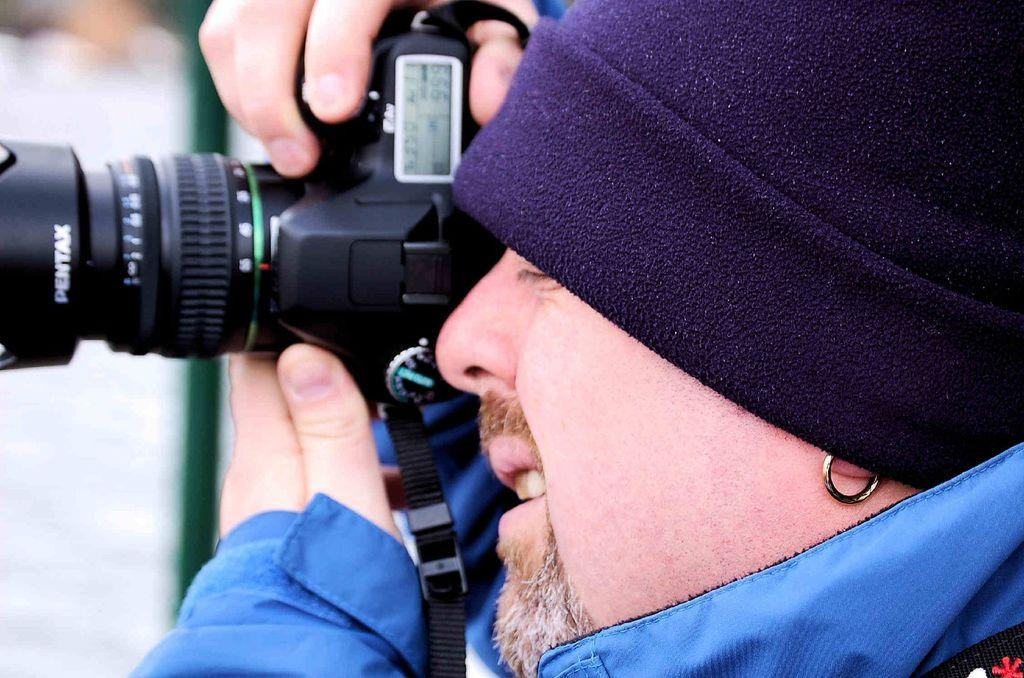Who is the main subject in the image? There is a man in the image. What is the man doing in the image? The man is taking a photograph. What tool is the man using to take the photograph? The man is using a camera to take the photograph. What type of cloth is the man using to take the photograph? There is no cloth mentioned or visible in the image; the man is using a camera to take the photograph. 